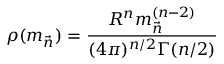<formula> <loc_0><loc_0><loc_500><loc_500>\rho ( { m } _ { \vec { n } } ) = \frac { R ^ { n } { { m } _ { \vec { n } } ^ { ( n - 2 ) } } } { ( 4 \pi ) ^ { n / 2 } \Gamma ( n / 2 ) }</formula> 